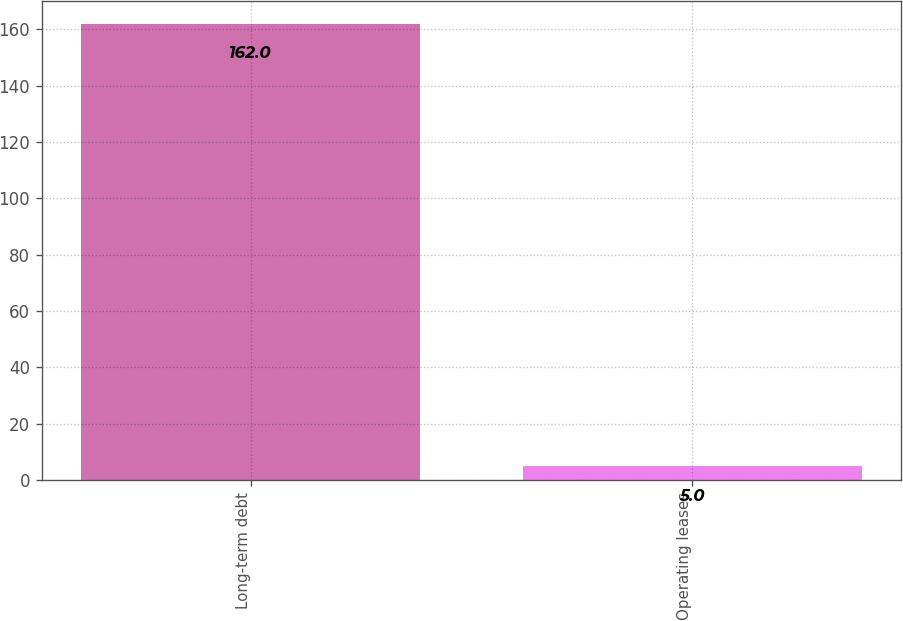<chart> <loc_0><loc_0><loc_500><loc_500><bar_chart><fcel>Long-term debt<fcel>Operating leases<nl><fcel>162<fcel>5<nl></chart> 